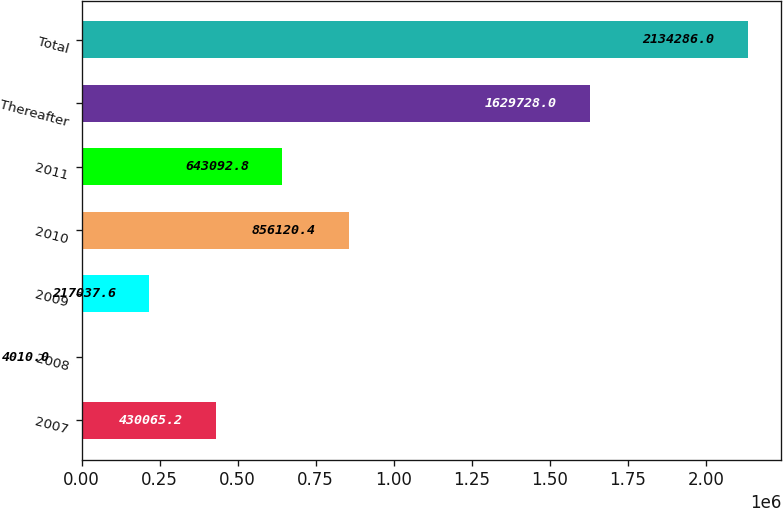Convert chart. <chart><loc_0><loc_0><loc_500><loc_500><bar_chart><fcel>2007<fcel>2008<fcel>2009<fcel>2010<fcel>2011<fcel>Thereafter<fcel>Total<nl><fcel>430065<fcel>4010<fcel>217038<fcel>856120<fcel>643093<fcel>1.62973e+06<fcel>2.13429e+06<nl></chart> 